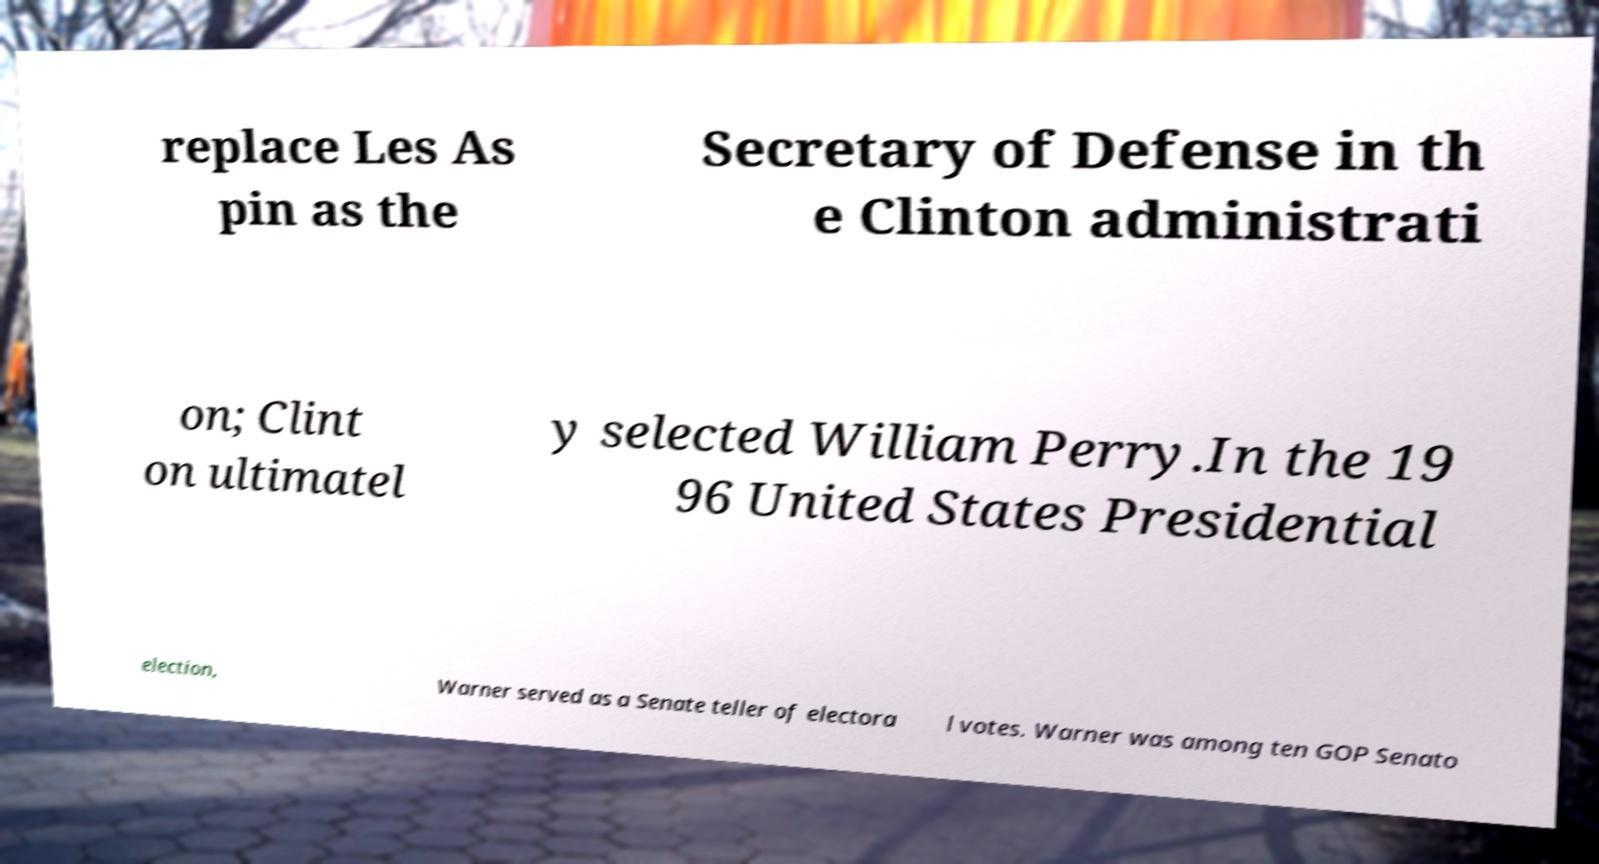What messages or text are displayed in this image? I need them in a readable, typed format. replace Les As pin as the Secretary of Defense in th e Clinton administrati on; Clint on ultimatel y selected William Perry.In the 19 96 United States Presidential election, Warner served as a Senate teller of electora l votes. Warner was among ten GOP Senato 